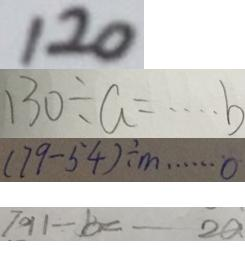Convert formula to latex. <formula><loc_0><loc_0><loc_500><loc_500>1 2 0 
 1 3 0 \div a = \cdots b 
 ( 7 9 - 5 4 ) \div m \cdots 0 
 7 9 1 \div b = - - 2 a</formula> 